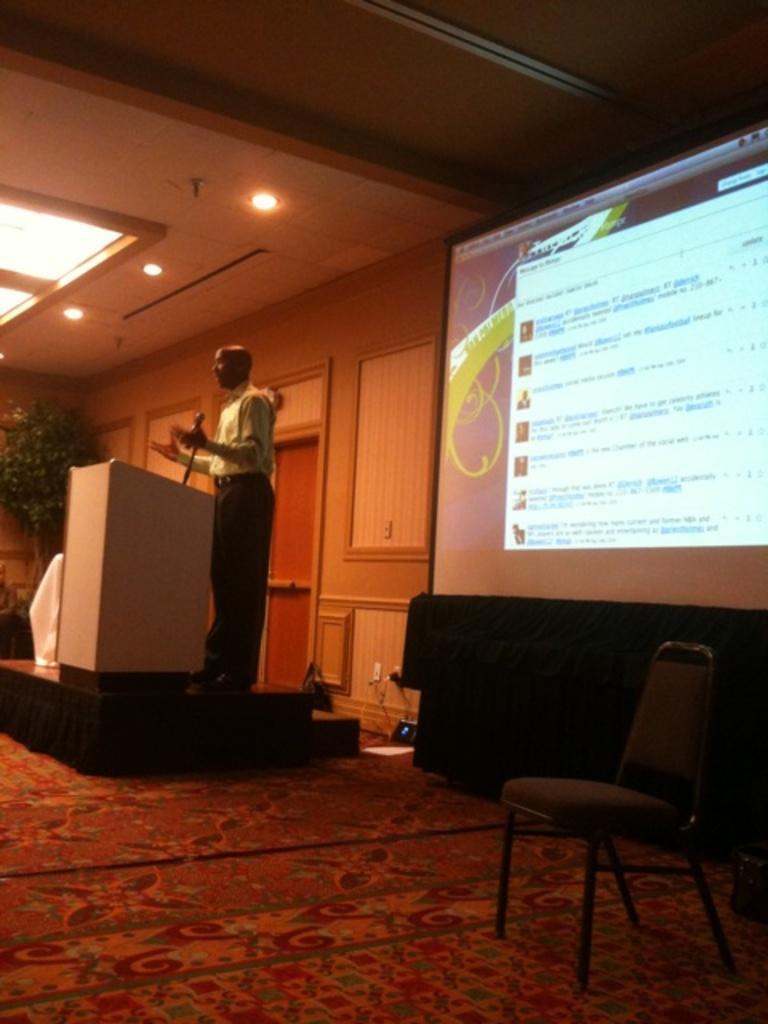Please provide a concise description of this image. In this image, there is a person wearing clothes and standing in front of the podium. There is a screen on the right side of the image. There is a chair in the bottom right of the image. There are some lights on the left side of the image. 